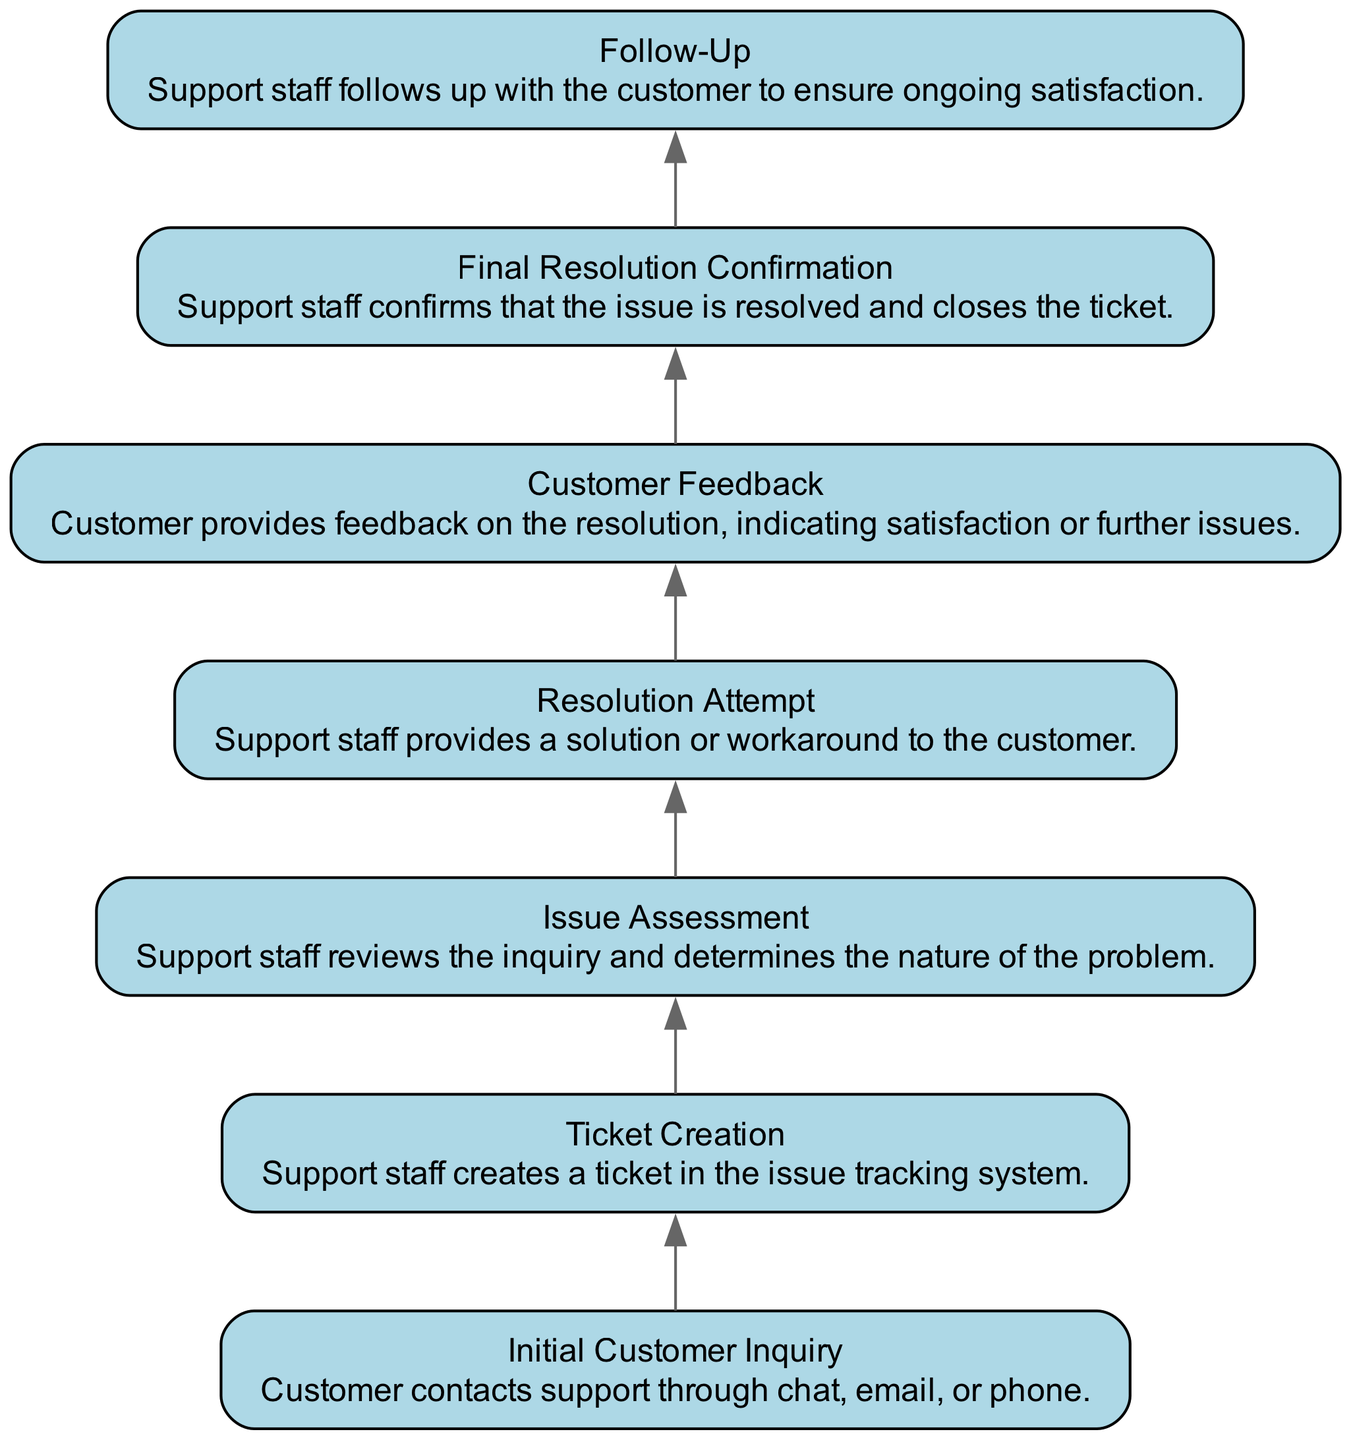What is the first step in the customer inquiry resolution process? The first step in the diagram is labeled "Initial Customer Inquiry". This is the starting point where the customer contacts support through chat, email, or phone.
Answer: Initial Customer Inquiry How many steps are there in the resolution process? To determine the number of steps, we count the nodes in the diagram. There are a total of 7 nodes representing different steps in the process.
Answer: 7 What step comes after "Ticket Creation"? According to the flow of the diagram, "Issue Assessment" directly follows "Ticket Creation". The edges connecting these nodes show the progression in the process.
Answer: Issue Assessment What is the last step of the customer inquiry resolution process? The final node in the diagram is labeled "Follow-Up". This indicates that after confirming the resolution of the issue, support staff will follow up with the customer.
Answer: Follow-Up Which step involves customer feedback? The diagram shows "Customer Feedback" as a distinct step in the process after the "Resolution Attempt". This signifies that support staff gathers feedback from the customer after attempting to resolve the issue.
Answer: Customer Feedback What relationship exists between "Resolution Attempt" and "Final Resolution Confirmation"? The relationship is sequential; "Resolution Attempt" leads to "Final Resolution Confirmation". This indicates that the final confirmation of resolution occurs after an attempt to provide a solution or workaround.
Answer: Sequential Which step directly follows "Issue Assessment"? The diagram indicates that "Resolution Attempt" is the next step that occurs directly after "Issue Assessment", indicating that staff attempts to resolve the customer's issue following the assessment.
Answer: Resolution Attempt 